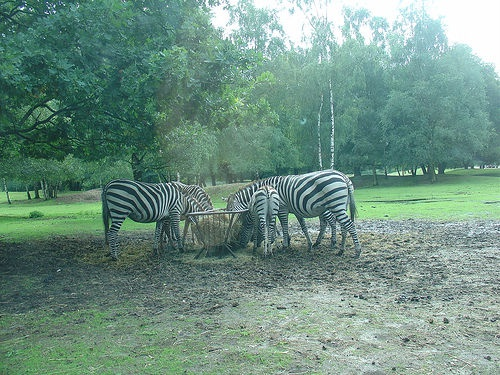Describe the objects in this image and their specific colors. I can see zebra in teal, black, and darkgray tones, zebra in teal, darkgray, and gray tones, and zebra in teal, darkgray, and gray tones in this image. 